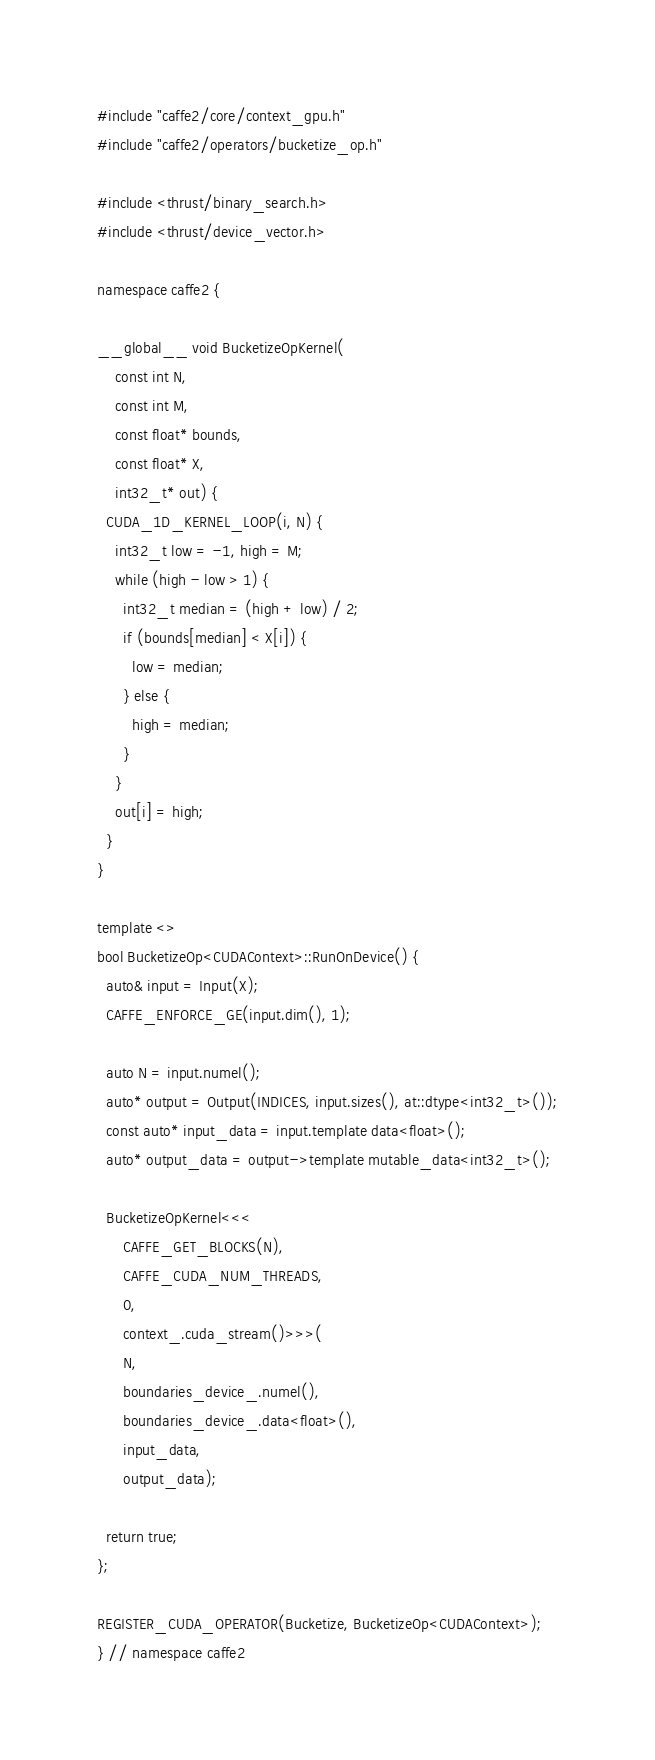Convert code to text. <code><loc_0><loc_0><loc_500><loc_500><_Cuda_>#include "caffe2/core/context_gpu.h"
#include "caffe2/operators/bucketize_op.h"

#include <thrust/binary_search.h>
#include <thrust/device_vector.h>

namespace caffe2 {

__global__ void BucketizeOpKernel(
    const int N,
    const int M,
    const float* bounds,
    const float* X,
    int32_t* out) {
  CUDA_1D_KERNEL_LOOP(i, N) {
    int32_t low = -1, high = M;
    while (high - low > 1) {
      int32_t median = (high + low) / 2;
      if (bounds[median] < X[i]) {
        low = median;
      } else {
        high = median;
      }
    }
    out[i] = high;
  }
}

template <>
bool BucketizeOp<CUDAContext>::RunOnDevice() {
  auto& input = Input(X);
  CAFFE_ENFORCE_GE(input.dim(), 1);

  auto N = input.numel();
  auto* output = Output(INDICES, input.sizes(), at::dtype<int32_t>());
  const auto* input_data = input.template data<float>();
  auto* output_data = output->template mutable_data<int32_t>();

  BucketizeOpKernel<<<
      CAFFE_GET_BLOCKS(N),
      CAFFE_CUDA_NUM_THREADS,
      0,
      context_.cuda_stream()>>>(
      N,
      boundaries_device_.numel(),
      boundaries_device_.data<float>(),
      input_data,
      output_data);

  return true;
};

REGISTER_CUDA_OPERATOR(Bucketize, BucketizeOp<CUDAContext>);
} // namespace caffe2
</code> 